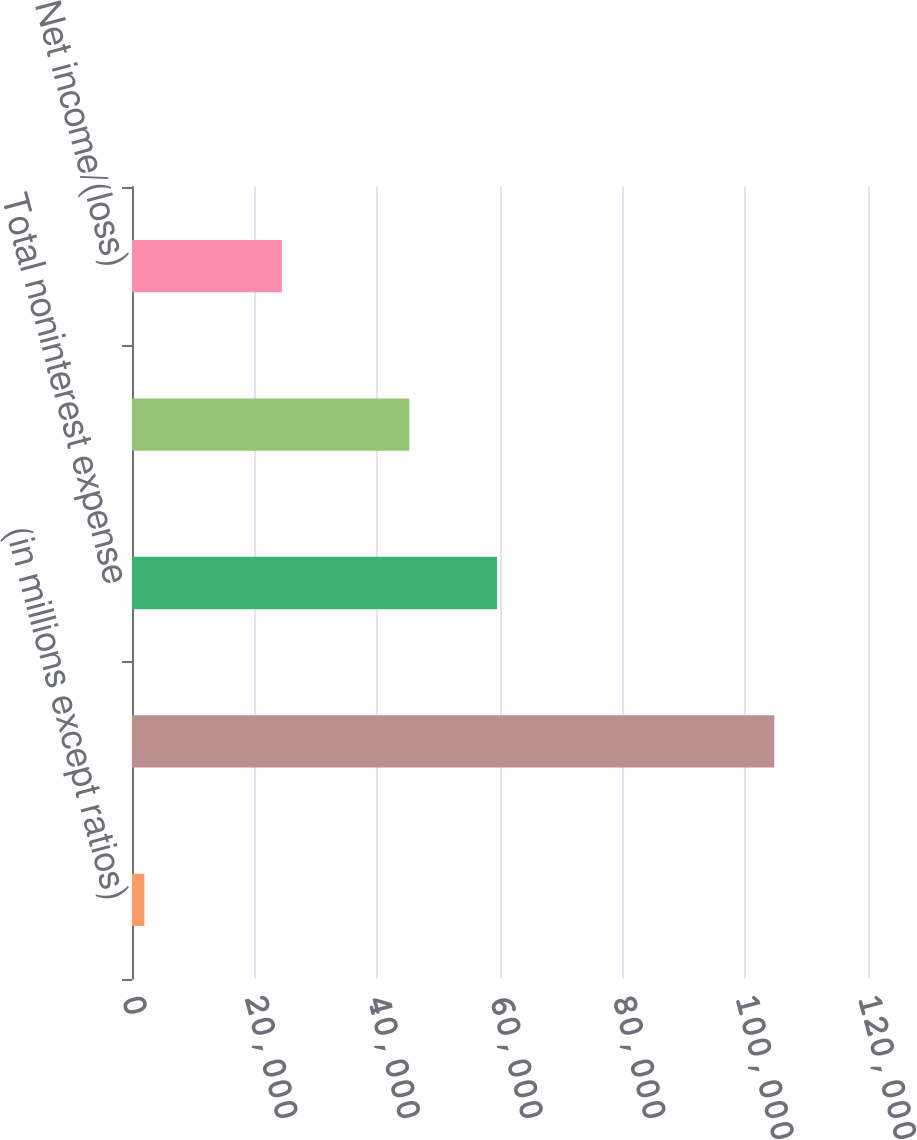<chart> <loc_0><loc_0><loc_500><loc_500><bar_chart><fcel>(in millions except ratios)<fcel>Total net revenue<fcel>Total noninterest expense<fcel>Pre-provision profit/(loss)<fcel>Net income/(loss)<nl><fcel>2017<fcel>104722<fcel>59515<fcel>45207<fcel>24441<nl></chart> 